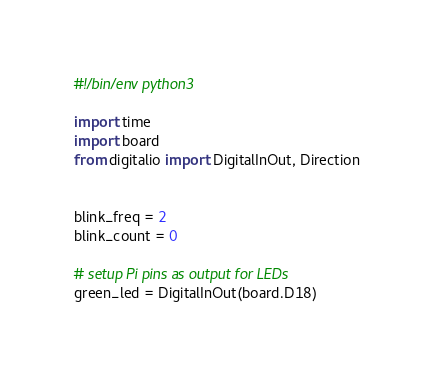Convert code to text. <code><loc_0><loc_0><loc_500><loc_500><_Python_>#!/bin/env python3

import time
import board
from digitalio import DigitalInOut, Direction


blink_freq = 2
blink_count = 0

# setup Pi pins as output for LEDs
green_led = DigitalInOut(board.D18)</code> 